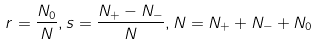Convert formula to latex. <formula><loc_0><loc_0><loc_500><loc_500>r = \frac { N _ { 0 } } N , \begin{array} { l } \end{array} s = \frac { N _ { + } - N _ { - } } N , \begin{array} { l } \end{array} N = N _ { + } + N _ { - } + N _ { 0 }</formula> 